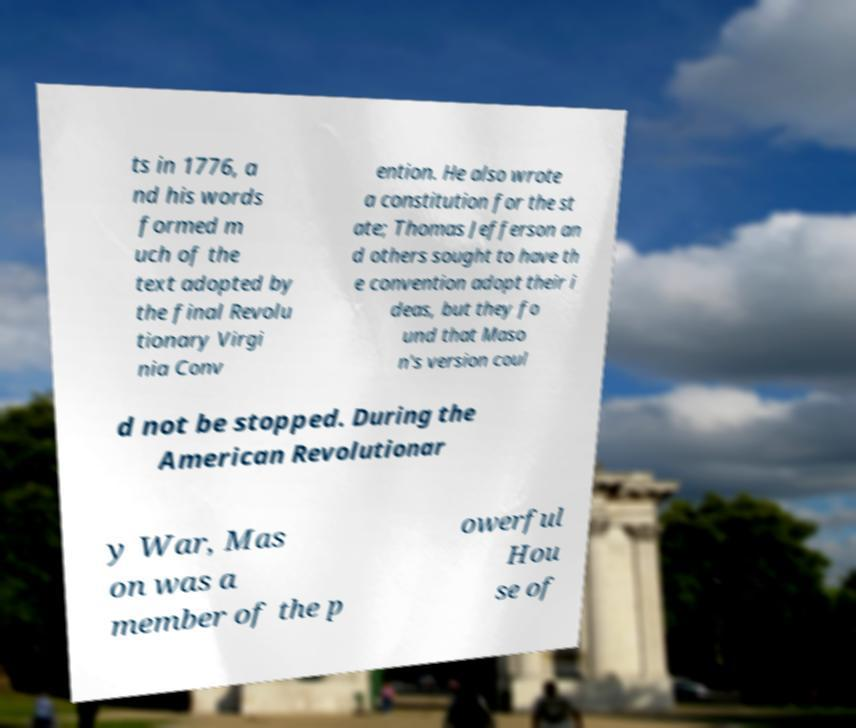What messages or text are displayed in this image? I need them in a readable, typed format. ts in 1776, a nd his words formed m uch of the text adopted by the final Revolu tionary Virgi nia Conv ention. He also wrote a constitution for the st ate; Thomas Jefferson an d others sought to have th e convention adopt their i deas, but they fo und that Maso n's version coul d not be stopped. During the American Revolutionar y War, Mas on was a member of the p owerful Hou se of 